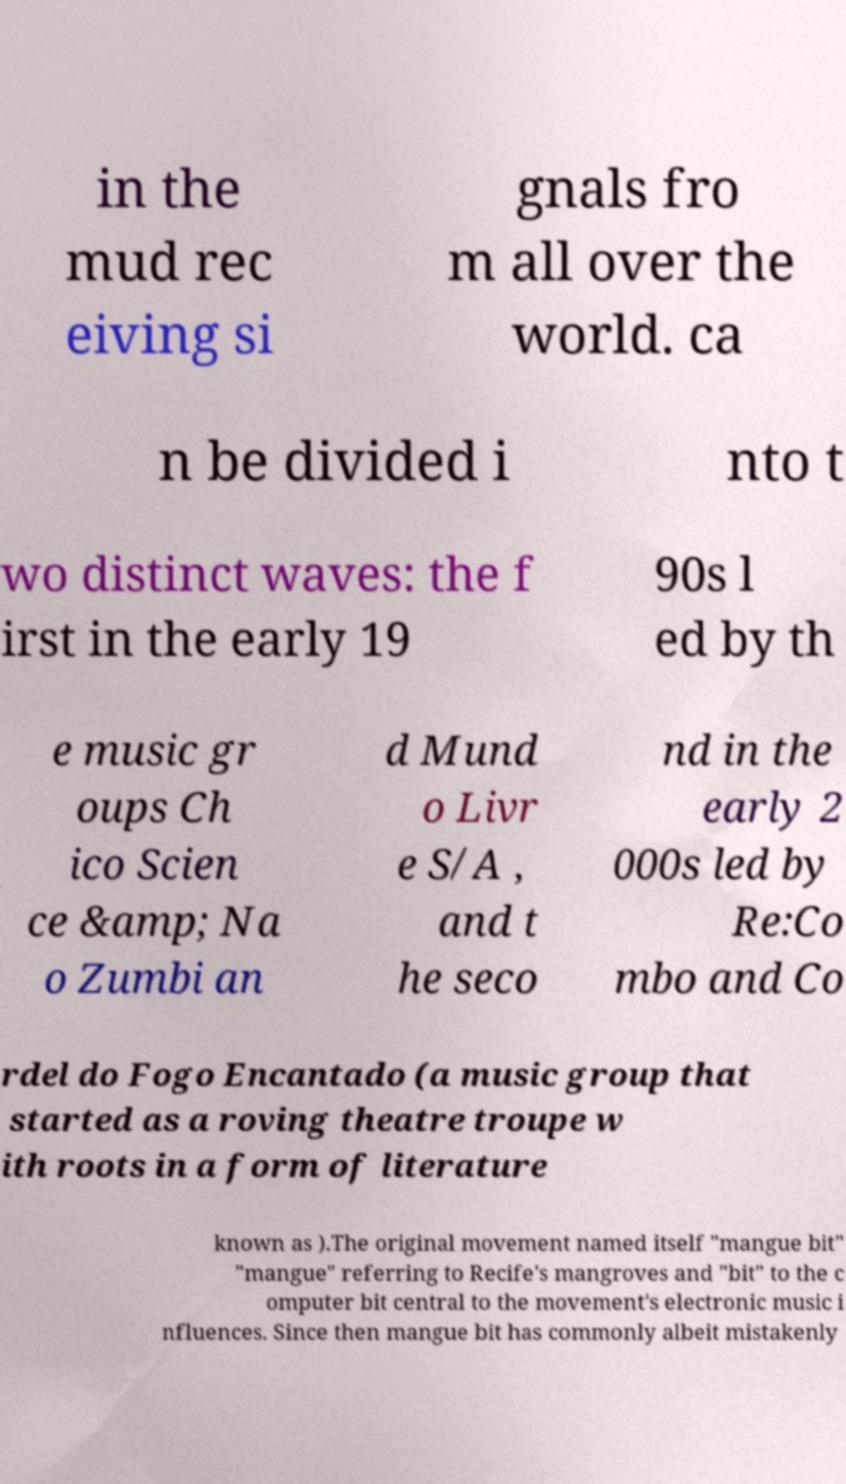Could you assist in decoding the text presented in this image and type it out clearly? in the mud rec eiving si gnals fro m all over the world. ca n be divided i nto t wo distinct waves: the f irst in the early 19 90s l ed by th e music gr oups Ch ico Scien ce &amp; Na o Zumbi an d Mund o Livr e S/A , and t he seco nd in the early 2 000s led by Re:Co mbo and Co rdel do Fogo Encantado (a music group that started as a roving theatre troupe w ith roots in a form of literature known as ).The original movement named itself "mangue bit" "mangue" referring to Recife's mangroves and "bit" to the c omputer bit central to the movement's electronic music i nfluences. Since then mangue bit has commonly albeit mistakenly 